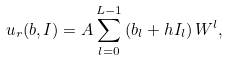<formula> <loc_0><loc_0><loc_500><loc_500>u _ { r } ( b , I ) = A \sum _ { l = 0 } ^ { L - 1 } \left ( b _ { l } + h I _ { l } \right ) W ^ { l } ,</formula> 